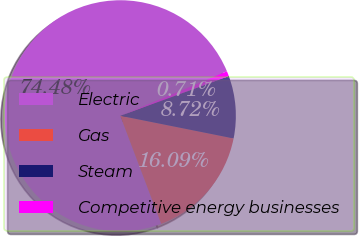<chart> <loc_0><loc_0><loc_500><loc_500><pie_chart><fcel>Electric<fcel>Gas<fcel>Steam<fcel>Competitive energy businesses<nl><fcel>74.47%<fcel>16.09%<fcel>8.72%<fcel>0.71%<nl></chart> 